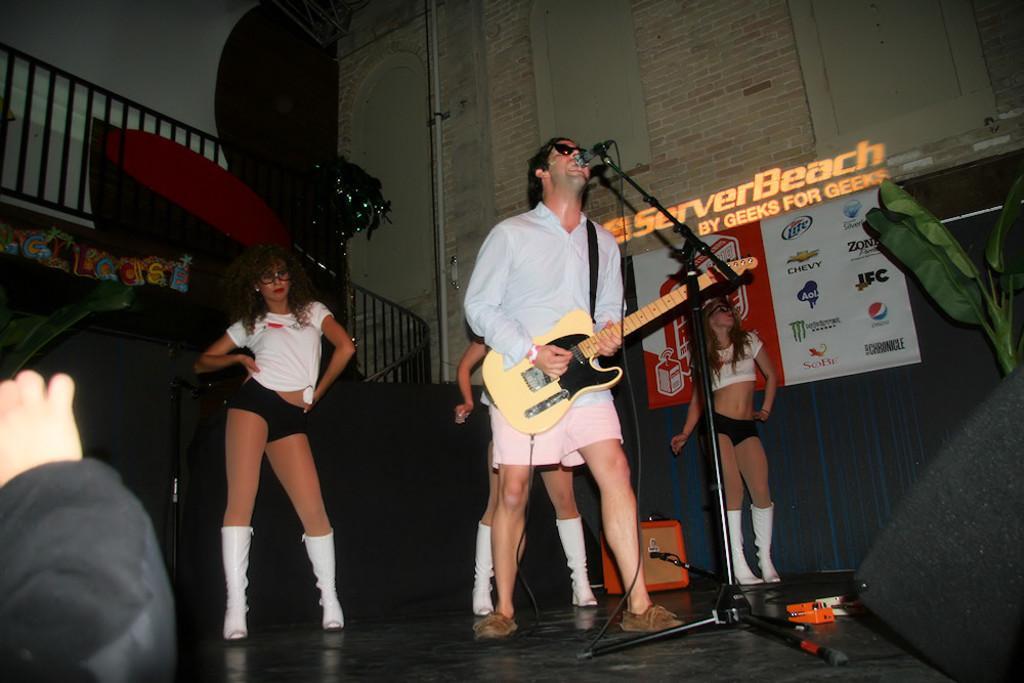Can you describe this image briefly? In this image In the middle there is a man he is playing guitar he wear white shirt, trouser and shoes he is singing and there is a mic in front of him. On the left there is a person. In the back ground there are three girls and they are dancing and wall, plant poster and text. 